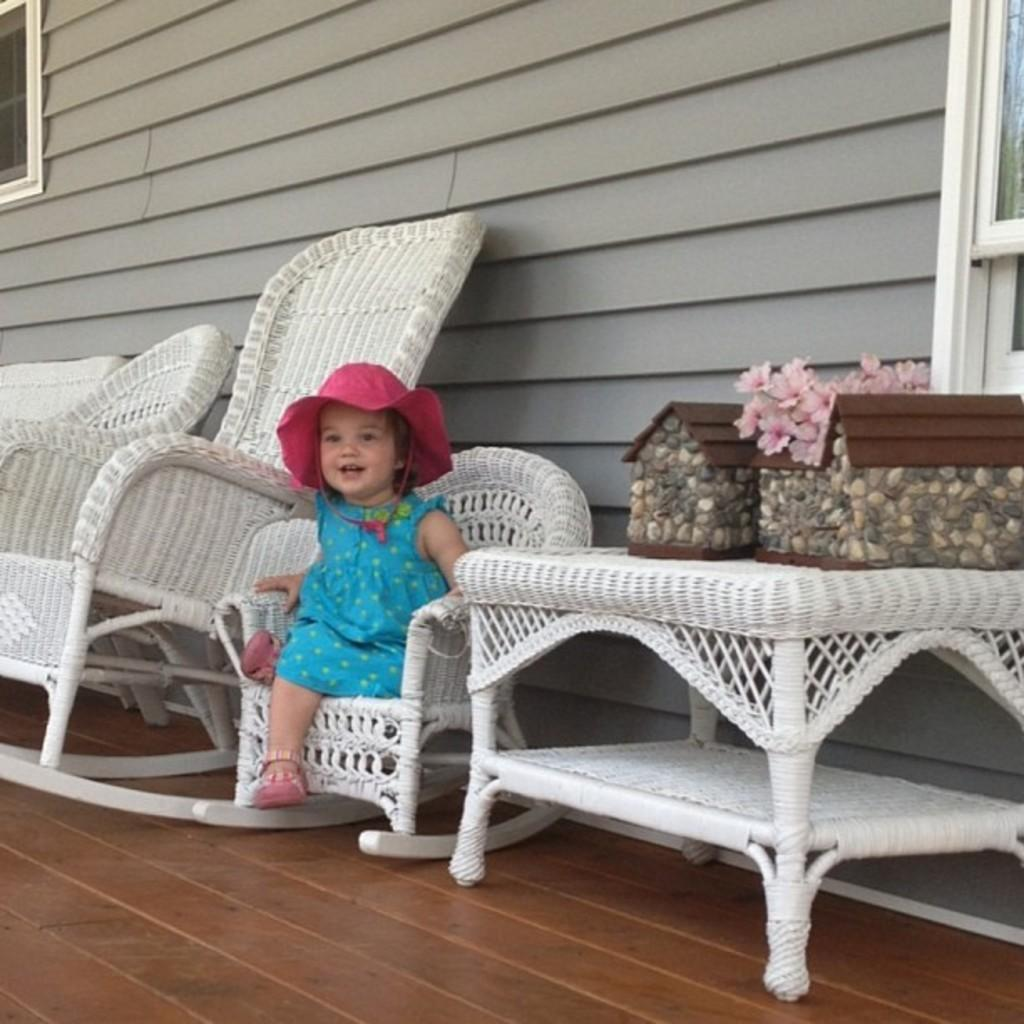What is the main subject of the image? There is a child in the image. What is the child wearing on their head? The child is wearing a hat. What is the child's facial expression? The child is smiling. What can be seen in the image besides the child? There are flowers visible in the image. What is present on a table in the image? There are objects on a table in the image. What can be seen in the background of the image? There is a wall with a window in the background of the image. What type of record can be heard playing in the background of the image? There is no record playing in the background of the image; it is a still image with no sound. What is the child using to whip the flowers in the image? There is no child using a whip in the image; the child is simply smiling and wearing a hat. 